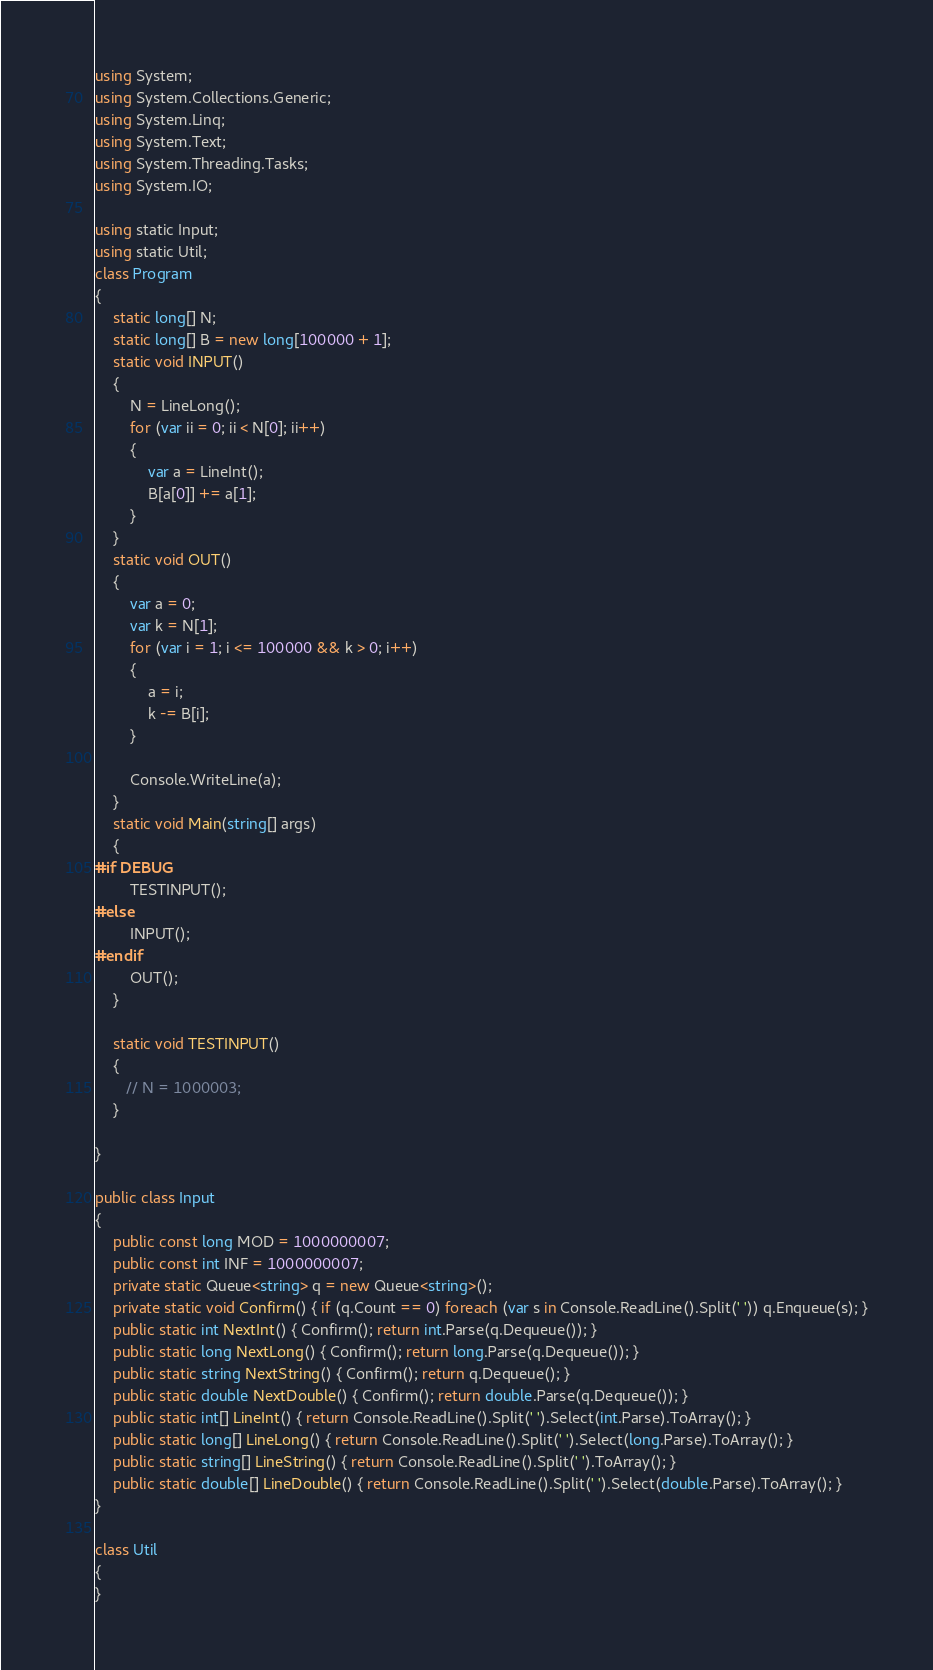<code> <loc_0><loc_0><loc_500><loc_500><_C#_>using System;
using System.Collections.Generic;
using System.Linq;
using System.Text;
using System.Threading.Tasks;
using System.IO;

using static Input;
using static Util;
class Program
{
    static long[] N;
    static long[] B = new long[100000 + 1];
    static void INPUT()
    {
        N = LineLong();
        for (var ii = 0; ii < N[0]; ii++)
        {
            var a = LineInt();
            B[a[0]] += a[1];
        }
    }
    static void OUT()
    {
        var a = 0;
        var k = N[1];
        for (var i = 1; i <= 100000 && k > 0; i++)
        {
            a = i;
            k -= B[i];
        }

        Console.WriteLine(a);
    }
    static void Main(string[] args)
    {
#if DEBUG  
        TESTINPUT();
#else
        INPUT();
#endif
        OUT();
    }

    static void TESTINPUT()
    {
       // N = 1000003;
    }

}

public class Input
{
    public const long MOD = 1000000007;
    public const int INF = 1000000007;
    private static Queue<string> q = new Queue<string>();
    private static void Confirm() { if (q.Count == 0) foreach (var s in Console.ReadLine().Split(' ')) q.Enqueue(s); }
    public static int NextInt() { Confirm(); return int.Parse(q.Dequeue()); }
    public static long NextLong() { Confirm(); return long.Parse(q.Dequeue()); }
    public static string NextString() { Confirm(); return q.Dequeue(); }
    public static double NextDouble() { Confirm(); return double.Parse(q.Dequeue()); }
    public static int[] LineInt() { return Console.ReadLine().Split(' ').Select(int.Parse).ToArray(); }
    public static long[] LineLong() { return Console.ReadLine().Split(' ').Select(long.Parse).ToArray(); }
    public static string[] LineString() { return Console.ReadLine().Split(' ').ToArray(); }
    public static double[] LineDouble() { return Console.ReadLine().Split(' ').Select(double.Parse).ToArray(); }
}

class Util
{
}


</code> 